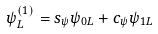Convert formula to latex. <formula><loc_0><loc_0><loc_500><loc_500>\psi _ { L } ^ { ( 1 ) } = s _ { \psi } \psi _ { 0 L } + c _ { \psi } \psi _ { 1 L }</formula> 